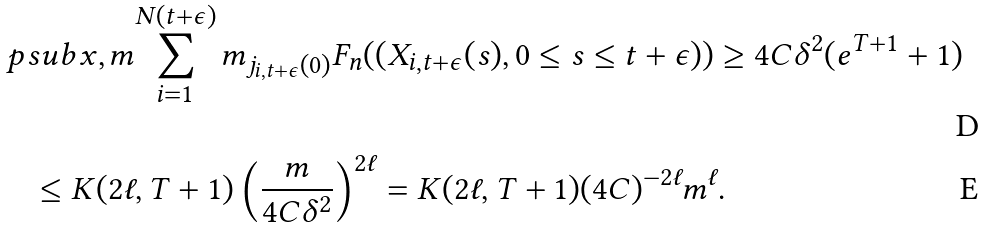<formula> <loc_0><loc_0><loc_500><loc_500>& \ p s u b { x , m } { \sum _ { i = 1 } ^ { N ( t + \epsilon ) } m _ { j _ { i , t + \epsilon } ( 0 ) } F _ { n } ( ( X _ { i , t + \epsilon } ( s ) , 0 \leq s \leq t + \epsilon ) ) \geq 4 C \delta ^ { 2 } ( e ^ { T + 1 } + 1 ) } \\ & \quad \leq K ( 2 \ell , T + 1 ) \left ( \frac { m } { 4 C \delta ^ { 2 } } \right ) ^ { 2 \ell } = K ( 2 \ell , T + 1 ) ( 4 C ) ^ { - 2 \ell } m ^ { \ell } .</formula> 